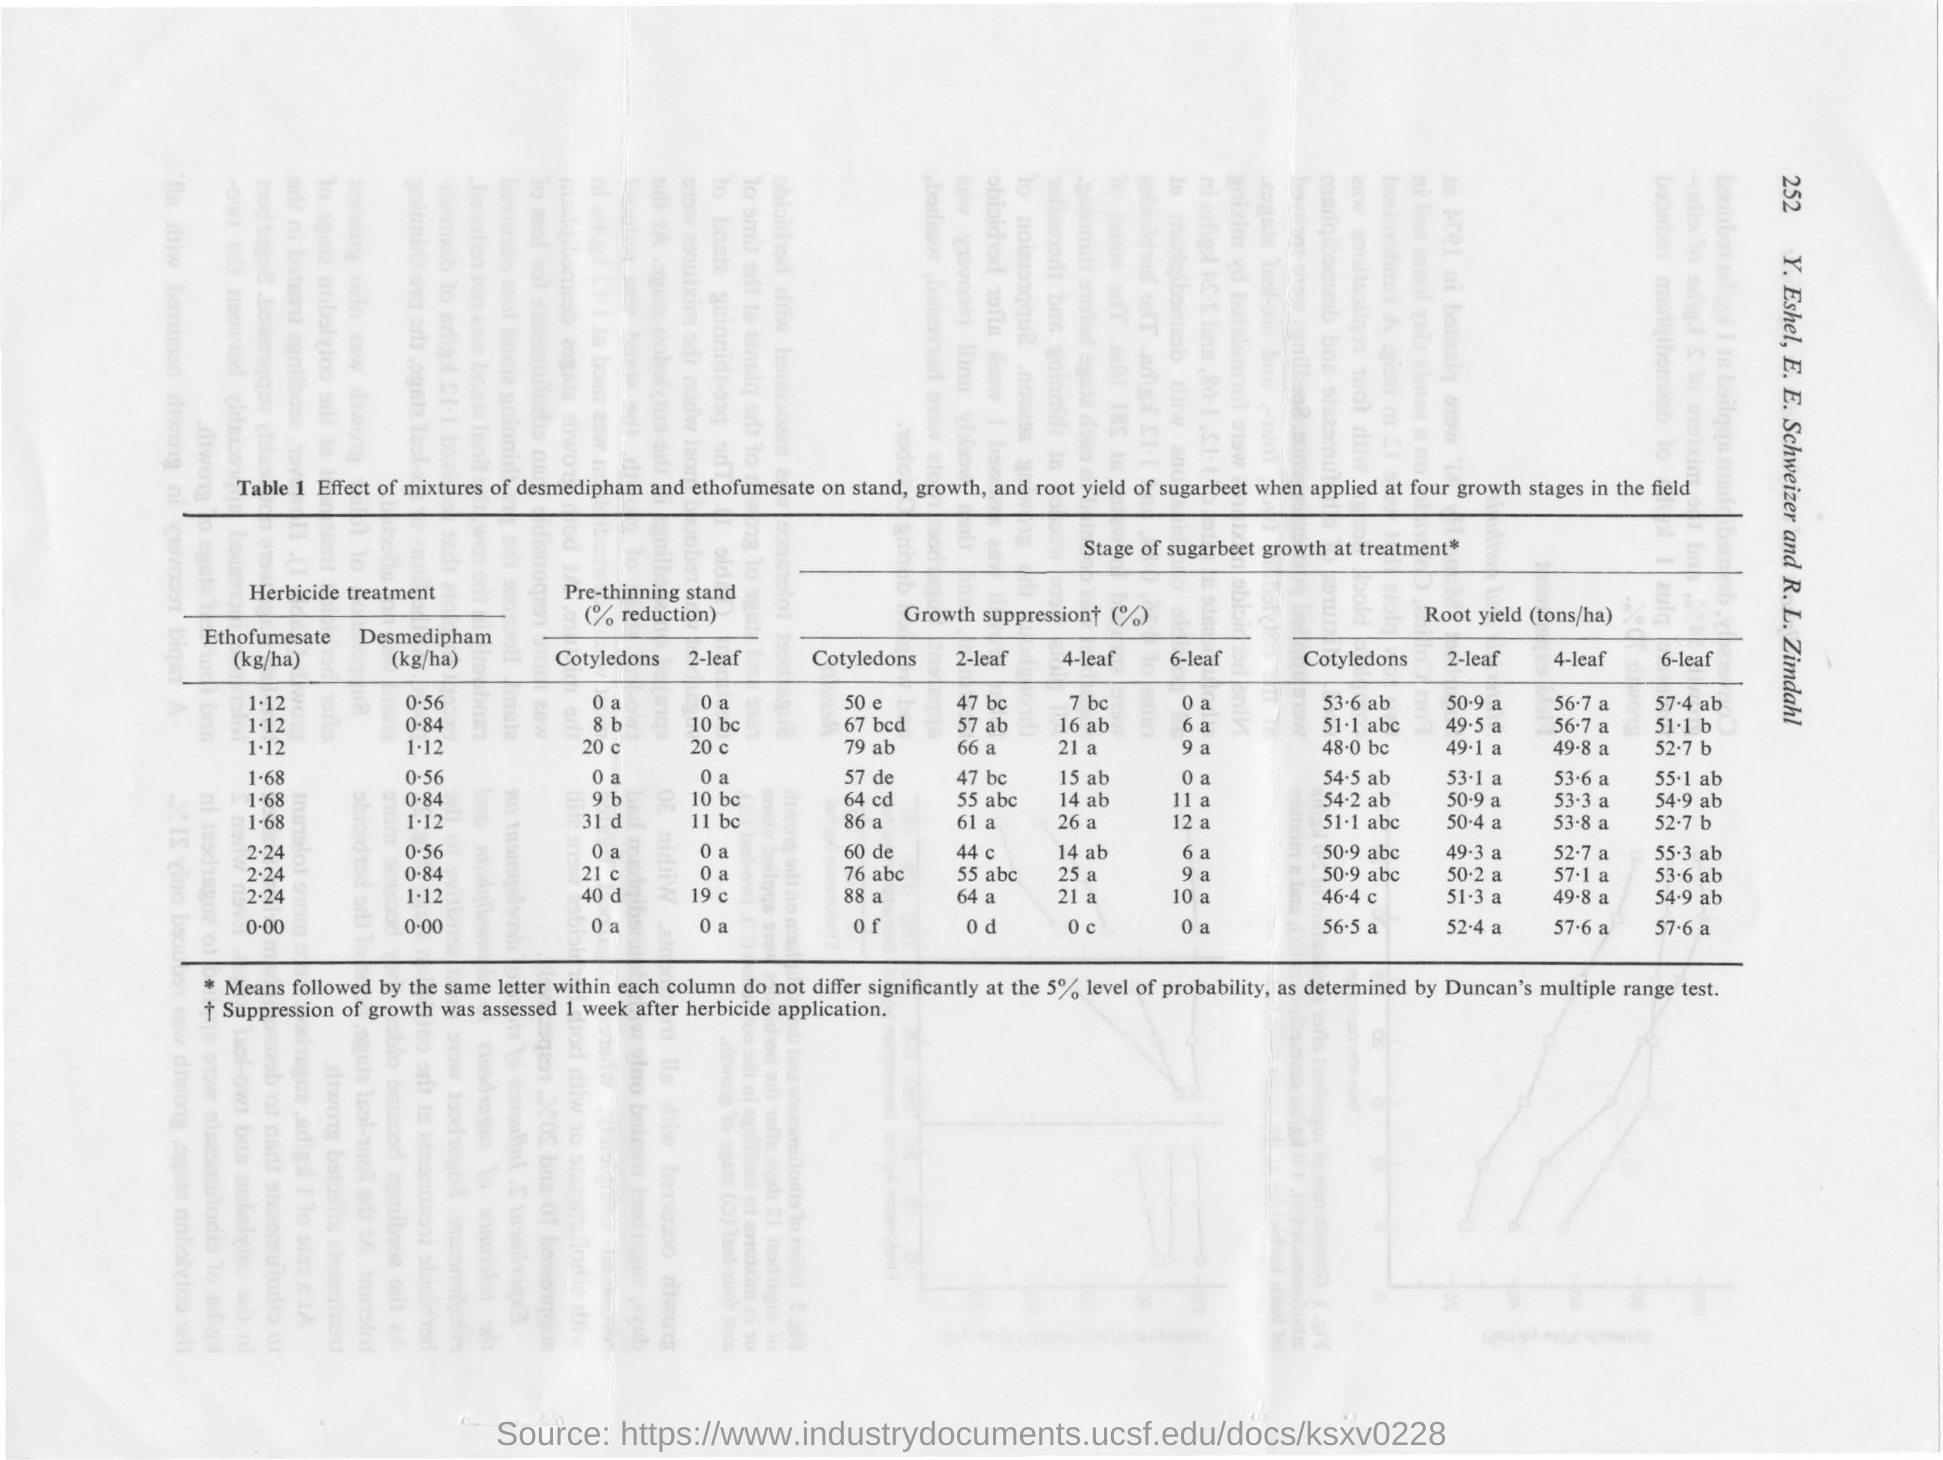Specify some key components in this picture. The growth stage of the product mentioned is sugarbeet. The page number mentioned is 252. 